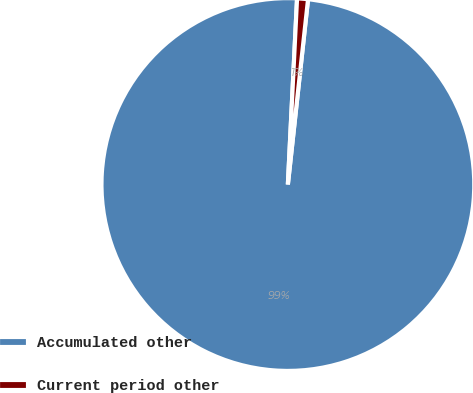Convert chart to OTSL. <chart><loc_0><loc_0><loc_500><loc_500><pie_chart><fcel>Accumulated other<fcel>Current period other<nl><fcel>99.06%<fcel>0.94%<nl></chart> 